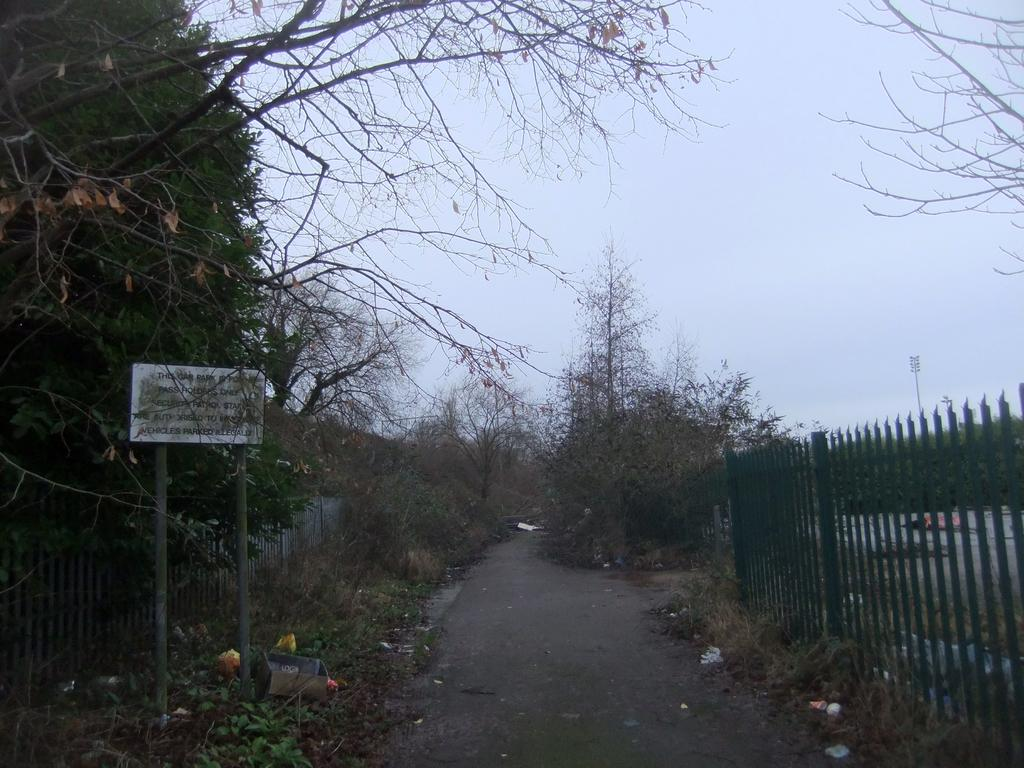What can be seen in the background of the image? The sky is visible in the background of the image. What is one of the main objects in the image? There is a board in the image. What are some other objects or structures present in the image? There are poles, railings, and a road in the image. What type of vegetation can be seen in the image? There are branches and trees in the image. What additional details can be observed in the image? There are objects and dried leaves present in the image. Can you tell me how many buttons are on the owl in the image? There is no owl present in the image, and therefore no buttons can be observed on it. What type of idea is being expressed by the objects in the image? The image does not convey any specific ideas; it simply presents a collection of objects and structures. 